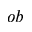Convert formula to latex. <formula><loc_0><loc_0><loc_500><loc_500>o b</formula> 